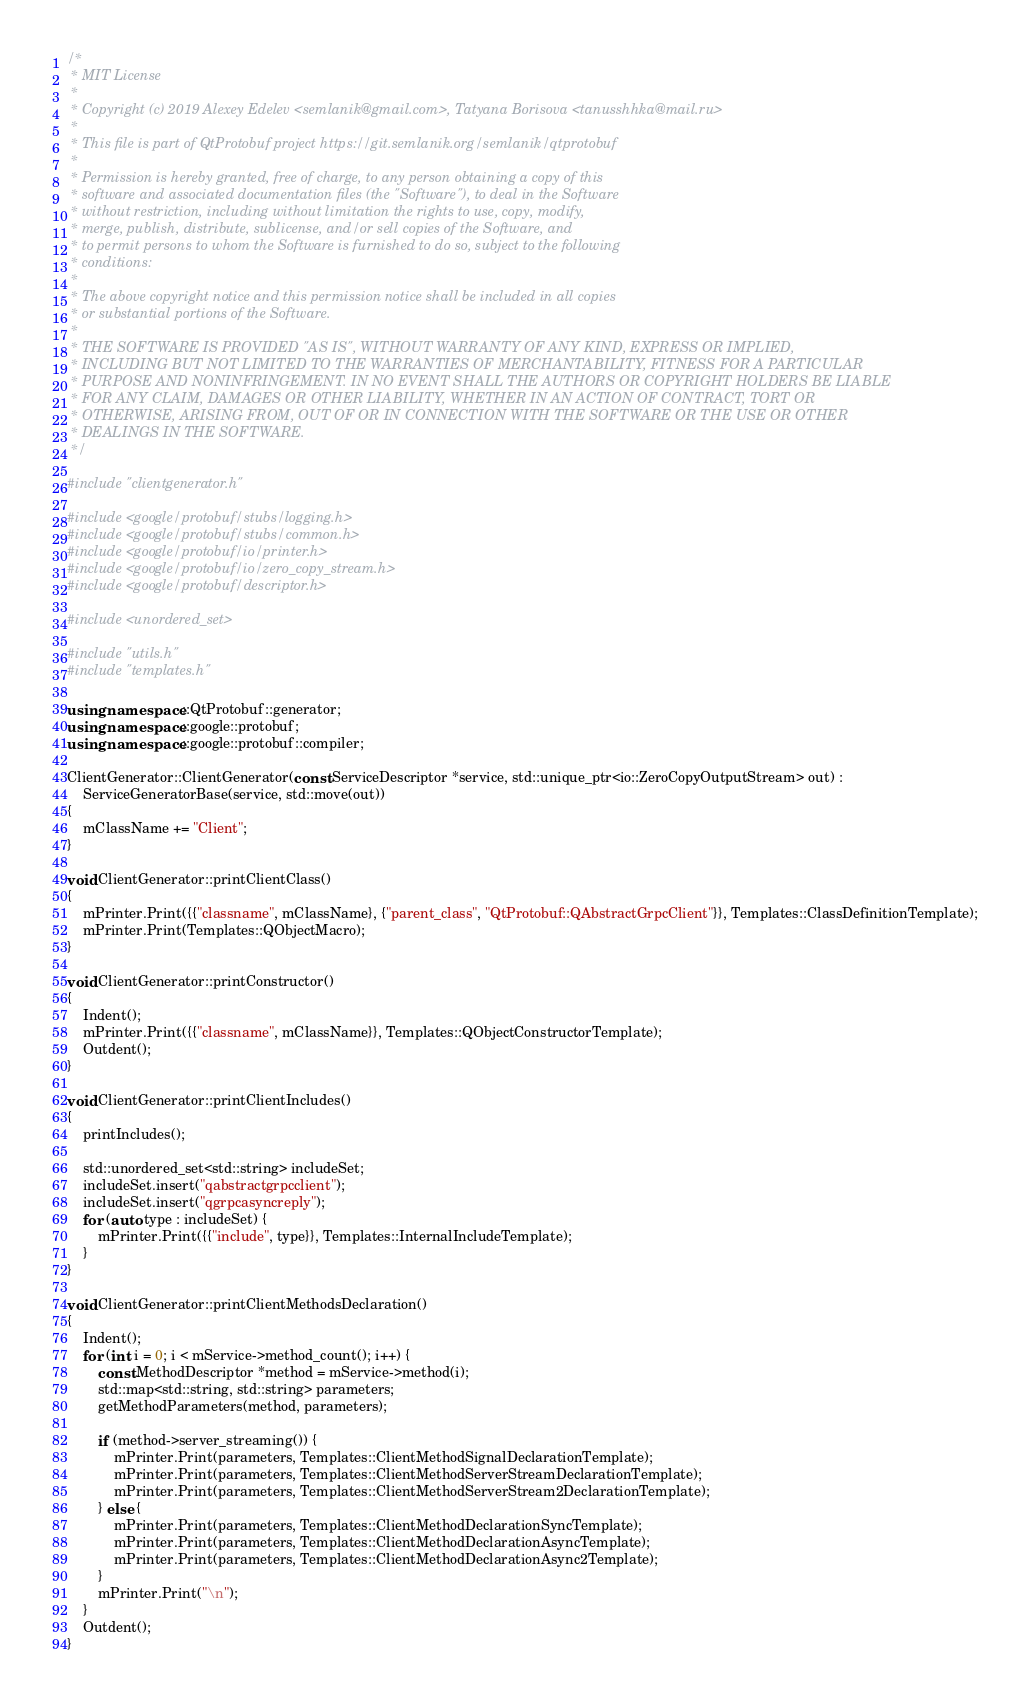Convert code to text. <code><loc_0><loc_0><loc_500><loc_500><_C++_>/*
 * MIT License
 *
 * Copyright (c) 2019 Alexey Edelev <semlanik@gmail.com>, Tatyana Borisova <tanusshhka@mail.ru>
 *
 * This file is part of QtProtobuf project https://git.semlanik.org/semlanik/qtprotobuf
 *
 * Permission is hereby granted, free of charge, to any person obtaining a copy of this
 * software and associated documentation files (the "Software"), to deal in the Software
 * without restriction, including without limitation the rights to use, copy, modify,
 * merge, publish, distribute, sublicense, and/or sell copies of the Software, and
 * to permit persons to whom the Software is furnished to do so, subject to the following
 * conditions:
 *
 * The above copyright notice and this permission notice shall be included in all copies
 * or substantial portions of the Software.
 *
 * THE SOFTWARE IS PROVIDED "AS IS", WITHOUT WARRANTY OF ANY KIND, EXPRESS OR IMPLIED,
 * INCLUDING BUT NOT LIMITED TO THE WARRANTIES OF MERCHANTABILITY, FITNESS FOR A PARTICULAR
 * PURPOSE AND NONINFRINGEMENT. IN NO EVENT SHALL THE AUTHORS OR COPYRIGHT HOLDERS BE LIABLE
 * FOR ANY CLAIM, DAMAGES OR OTHER LIABILITY, WHETHER IN AN ACTION OF CONTRACT, TORT OR
 * OTHERWISE, ARISING FROM, OUT OF OR IN CONNECTION WITH THE SOFTWARE OR THE USE OR OTHER
 * DEALINGS IN THE SOFTWARE.
 */

#include "clientgenerator.h"

#include <google/protobuf/stubs/logging.h>
#include <google/protobuf/stubs/common.h>
#include <google/protobuf/io/printer.h>
#include <google/protobuf/io/zero_copy_stream.h>
#include <google/protobuf/descriptor.h>

#include <unordered_set>

#include "utils.h"
#include "templates.h"

using namespace ::QtProtobuf::generator;
using namespace ::google::protobuf;
using namespace ::google::protobuf::compiler;

ClientGenerator::ClientGenerator(const ServiceDescriptor *service, std::unique_ptr<io::ZeroCopyOutputStream> out) :
    ServiceGeneratorBase(service, std::move(out))
{
    mClassName += "Client";
}

void ClientGenerator::printClientClass()
{
    mPrinter.Print({{"classname", mClassName}, {"parent_class", "QtProtobuf::QAbstractGrpcClient"}}, Templates::ClassDefinitionTemplate);
    mPrinter.Print(Templates::QObjectMacro);
}

void ClientGenerator::printConstructor()
{
    Indent();
    mPrinter.Print({{"classname", mClassName}}, Templates::QObjectConstructorTemplate);
    Outdent();
}

void ClientGenerator::printClientIncludes()
{
    printIncludes();

    std::unordered_set<std::string> includeSet;
    includeSet.insert("qabstractgrpcclient");
    includeSet.insert("qgrpcasyncreply");
    for (auto type : includeSet) {
        mPrinter.Print({{"include", type}}, Templates::InternalIncludeTemplate);
    }
}

void ClientGenerator::printClientMethodsDeclaration()
{
    Indent();
    for (int i = 0; i < mService->method_count(); i++) {
        const MethodDescriptor *method = mService->method(i);
        std::map<std::string, std::string> parameters;
        getMethodParameters(method, parameters);

        if (method->server_streaming()) {
            mPrinter.Print(parameters, Templates::ClientMethodSignalDeclarationTemplate);
            mPrinter.Print(parameters, Templates::ClientMethodServerStreamDeclarationTemplate);
            mPrinter.Print(parameters, Templates::ClientMethodServerStream2DeclarationTemplate);
        } else {
            mPrinter.Print(parameters, Templates::ClientMethodDeclarationSyncTemplate);
            mPrinter.Print(parameters, Templates::ClientMethodDeclarationAsyncTemplate);
            mPrinter.Print(parameters, Templates::ClientMethodDeclarationAsync2Template);
        }
        mPrinter.Print("\n");
    }
    Outdent();
}
</code> 